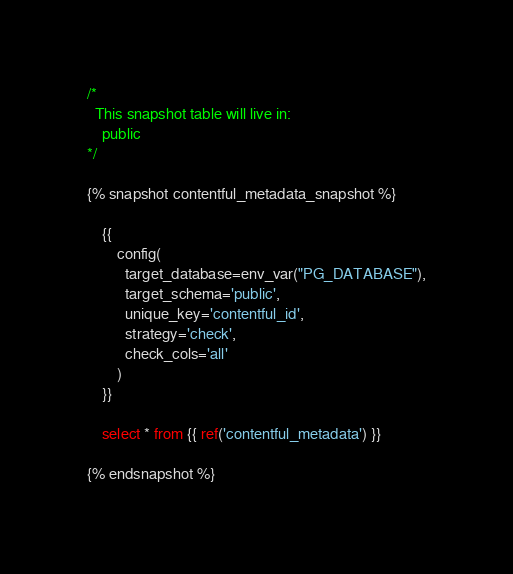Convert code to text. <code><loc_0><loc_0><loc_500><loc_500><_SQL_>/*
  This snapshot table will live in:
    public
*/

{% snapshot contentful_metadata_snapshot %}

    {{
        config(
          target_database=env_var("PG_DATABASE"),
          target_schema='public',
          unique_key='contentful_id',
          strategy='check',
          check_cols='all'
        )
    }}
    
    select * from {{ ref('contentful_metadata') }}
    
{% endsnapshot %}
</code> 